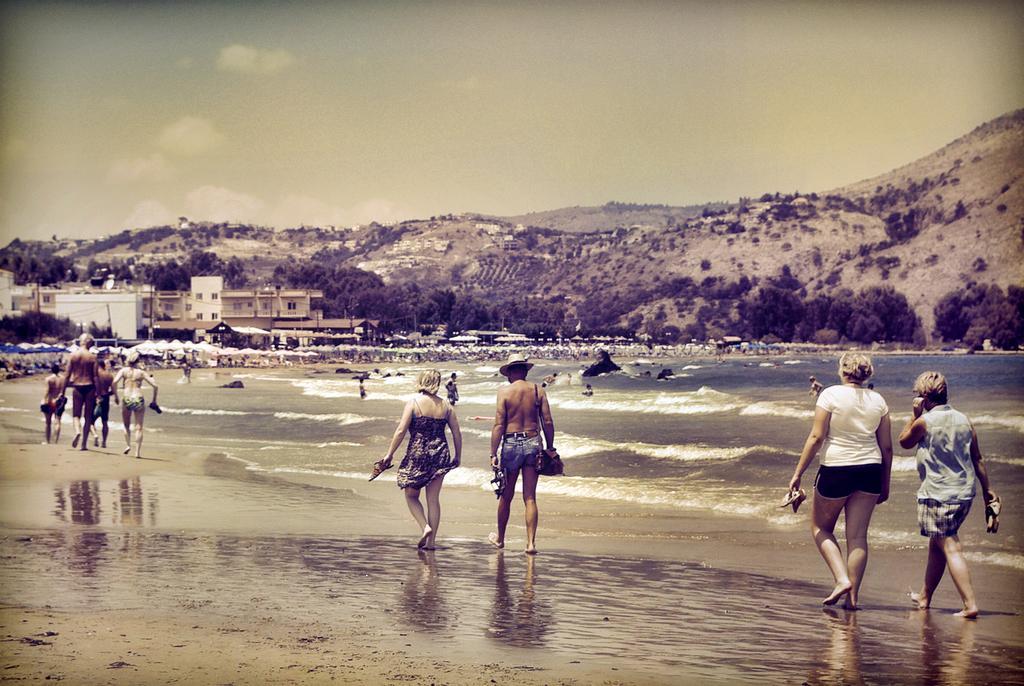Could you give a brief overview of what you see in this image? In this image we can see these people are walking on the beach. In the background, we can see umbrellas, chairs, water, buildings, hills and the sky with clouds. 